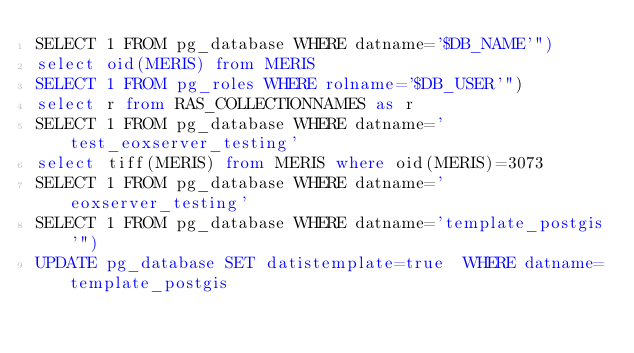Convert code to text. <code><loc_0><loc_0><loc_500><loc_500><_SQL_>SELECT 1 FROM pg_database WHERE datname='$DB_NAME'")
select oid(MERIS) from MERIS
SELECT 1 FROM pg_roles WHERE rolname='$DB_USER'")
select r from RAS_COLLECTIONNAMES as r
SELECT 1 FROM pg_database WHERE datname='test_eoxserver_testing'
select tiff(MERIS) from MERIS where oid(MERIS)=3073
SELECT 1 FROM pg_database WHERE datname='eoxserver_testing'
SELECT 1 FROM pg_database WHERE datname='template_postgis'")
UPDATE pg_database SET datistemplate=true  WHERE datname=template_postgis
</code> 